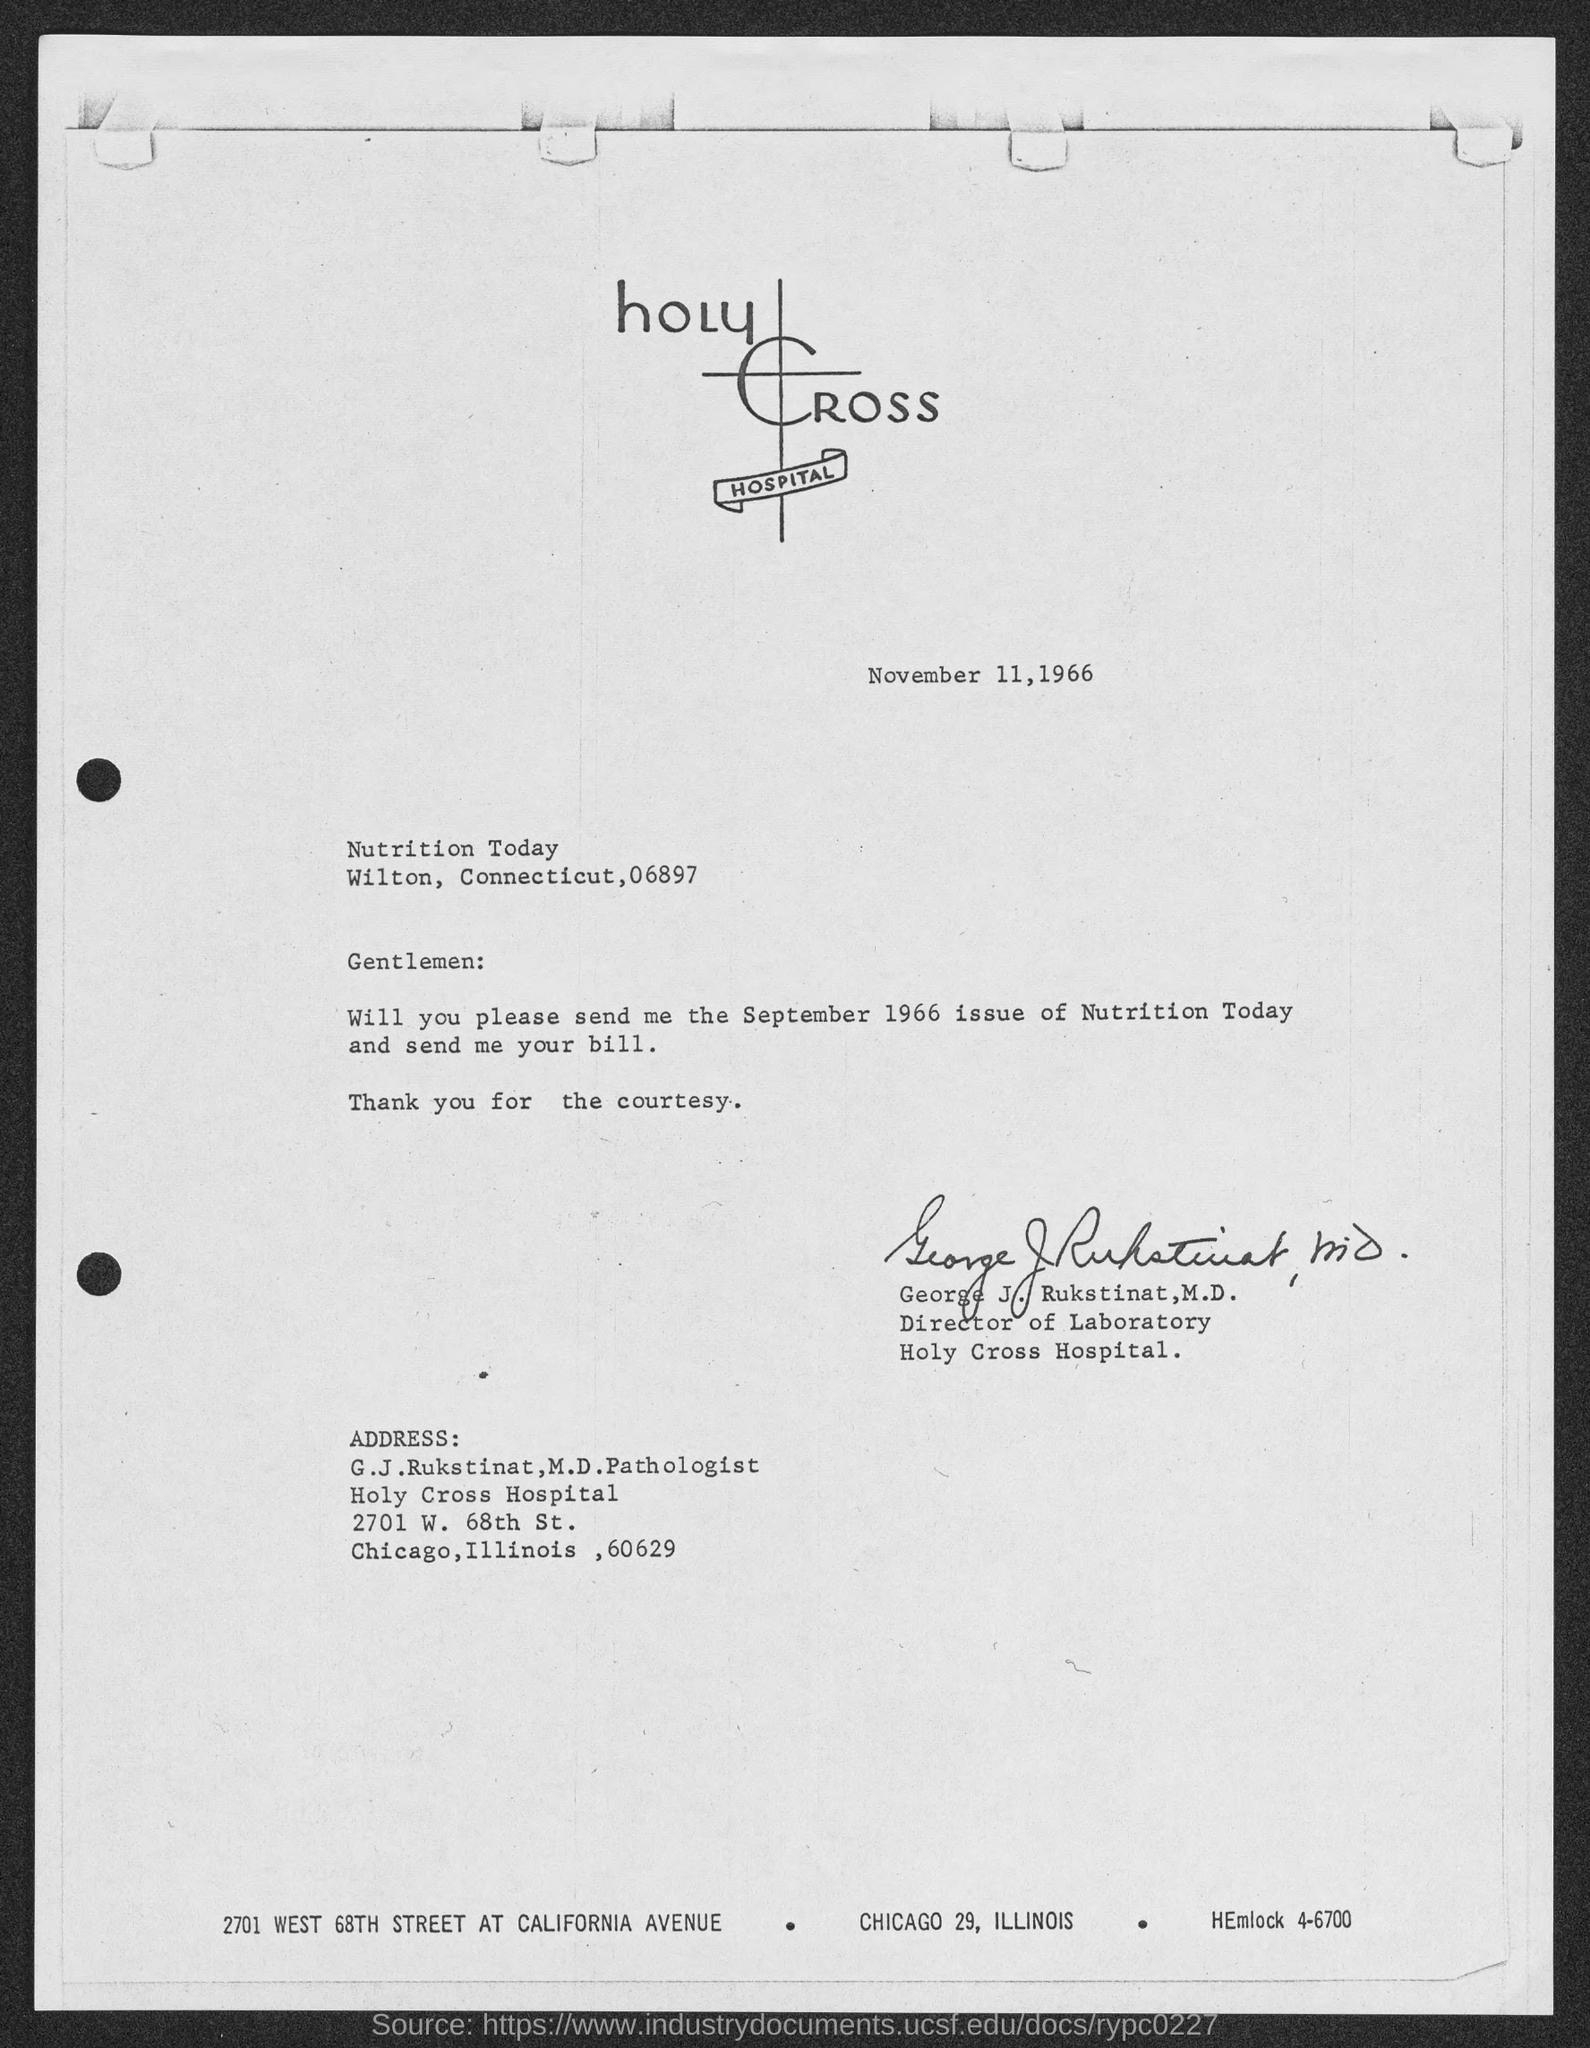What is the date mentioned in the top of the document ?
Provide a short and direct response. November 11, 1966. 